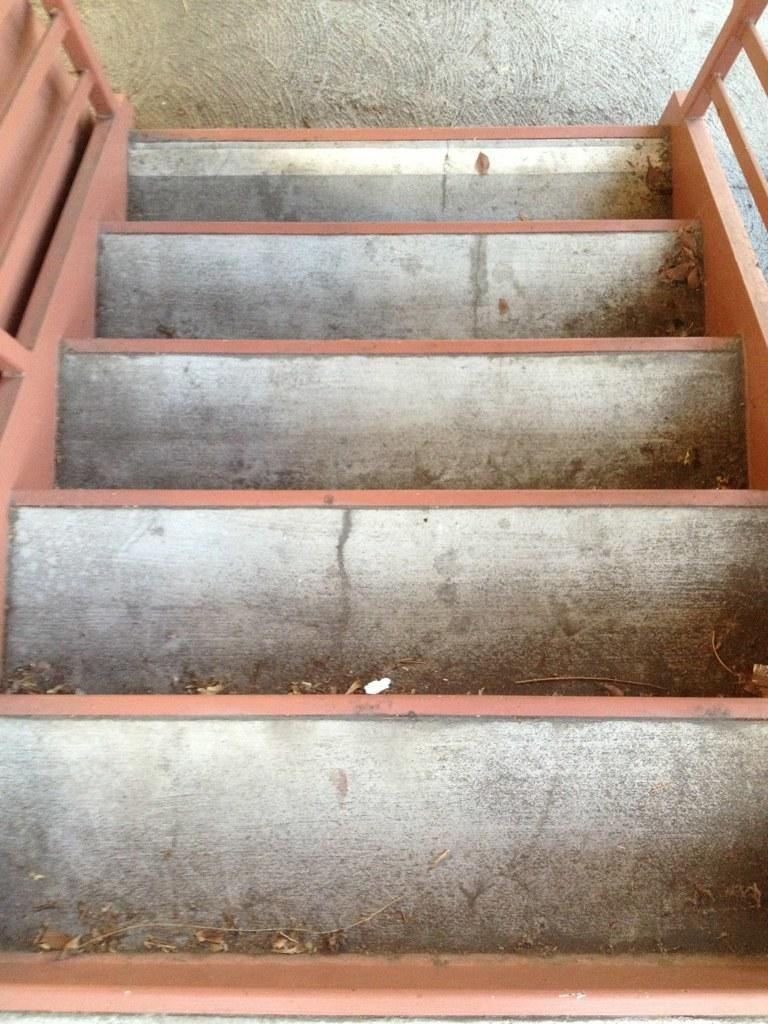What type of structure is present in the image? There is a staircase in the image. Can you describe the staircase in more detail? Unfortunately, the provided facts do not offer any additional details about the staircase. Is there any other object or structure visible in the image? No, the only information given is that there is a staircase in the image. Is there a volleyball game taking place on the side of the staircase in the image? No, there is no mention of a volleyball game or any other activity taking place in the image. 